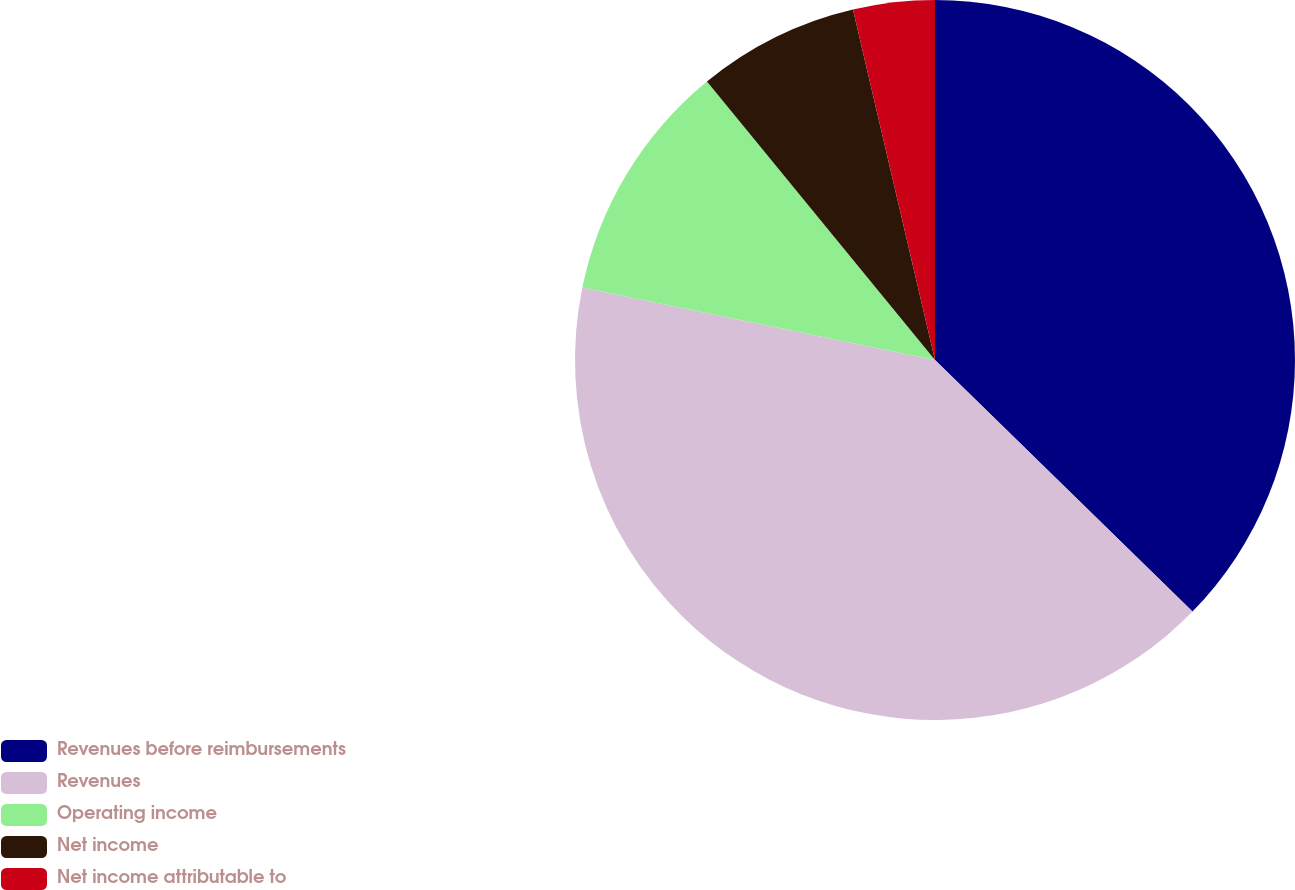Convert chart. <chart><loc_0><loc_0><loc_500><loc_500><pie_chart><fcel>Revenues before reimbursements<fcel>Revenues<fcel>Operating income<fcel>Net income<fcel>Net income attributable to<nl><fcel>37.32%<fcel>40.91%<fcel>10.86%<fcel>7.26%<fcel>3.66%<nl></chart> 